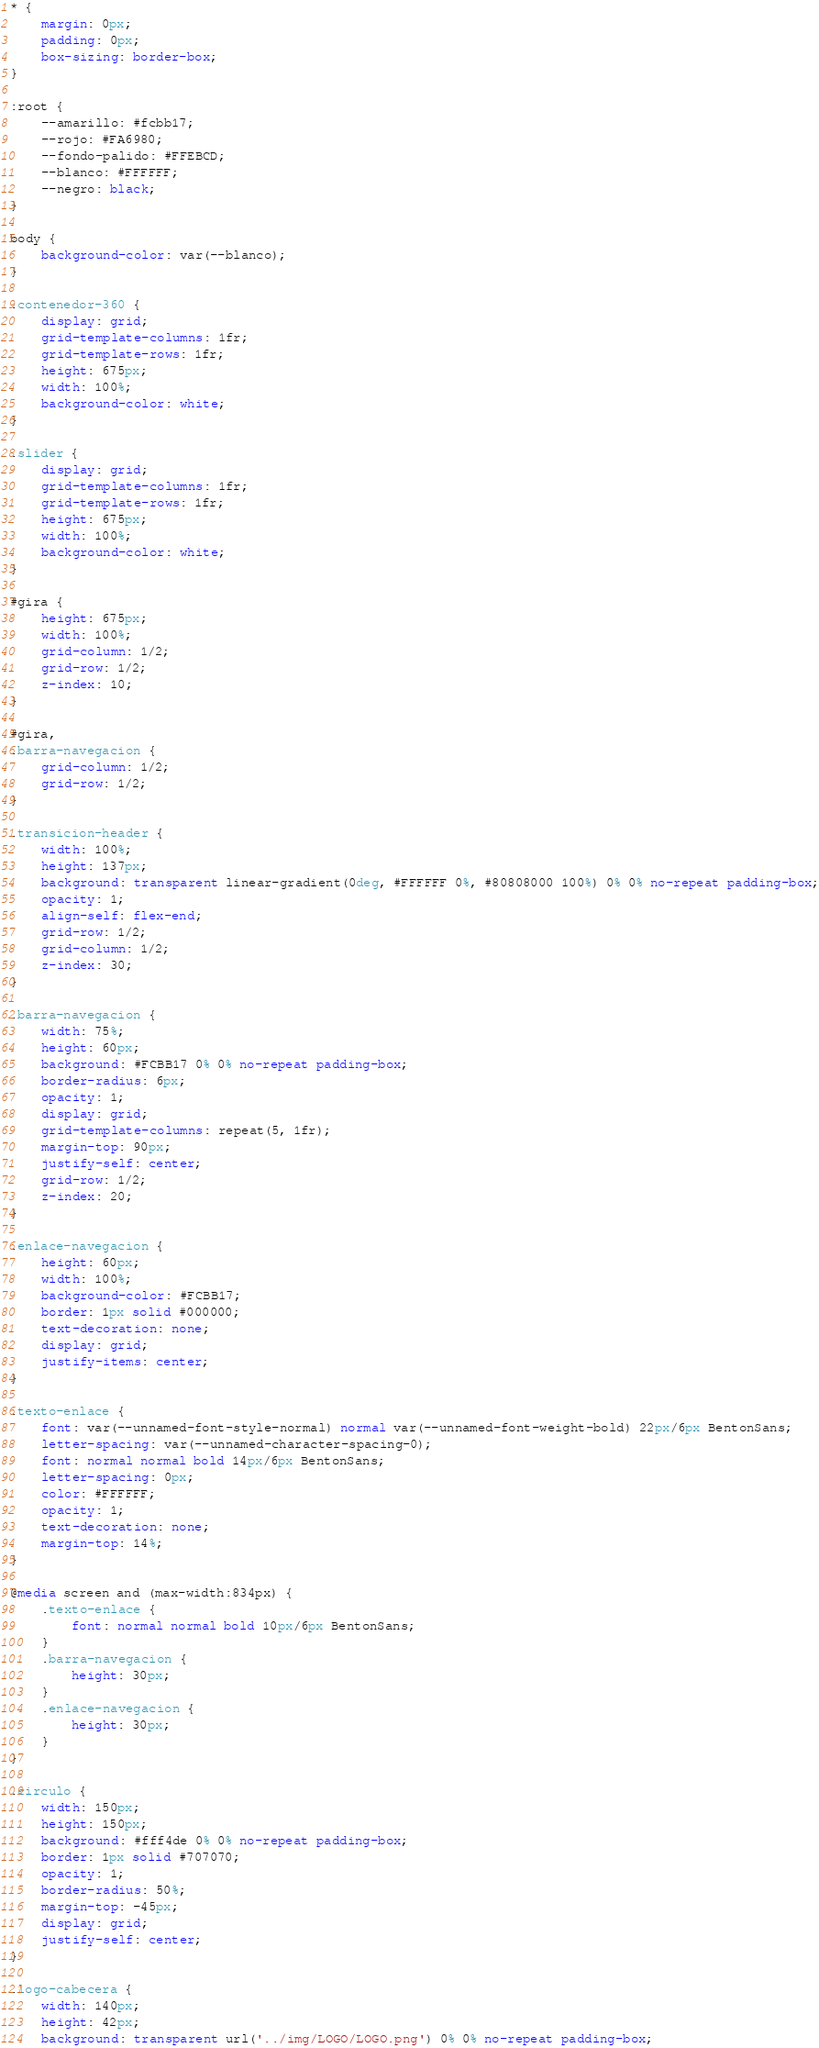<code> <loc_0><loc_0><loc_500><loc_500><_CSS_>* {
    margin: 0px;
    padding: 0px;
    box-sizing: border-box;
}

:root {
    --amarillo: #fcbb17;
    --rojo: #FA6980;
    --fondo-palido: #FFEBCD;
    --blanco: #FFFFFF;
    --negro: black;
}

body {
    background-color: var(--blanco);
}

.contenedor-360 {
    display: grid;
    grid-template-columns: 1fr;
    grid-template-rows: 1fr;
    height: 675px;
    width: 100%;
    background-color: white;
}

.slider {
    display: grid;
    grid-template-columns: 1fr;
    grid-template-rows: 1fr;
    height: 675px;
    width: 100%;
    background-color: white;
}

#gira {
    height: 675px;
    width: 100%;
    grid-column: 1/2;
    grid-row: 1/2;
    z-index: 10;
}

#gira,
.barra-navegacion {
    grid-column: 1/2;
    grid-row: 1/2;
}

.transicion-header {
    width: 100%;
    height: 137px;
    background: transparent linear-gradient(0deg, #FFFFFF 0%, #80808000 100%) 0% 0% no-repeat padding-box;
    opacity: 1;
    align-self: flex-end;
    grid-row: 1/2;
    grid-column: 1/2;
    z-index: 30;
}

.barra-navegacion {
    width: 75%;
    height: 60px;
    background: #FCBB17 0% 0% no-repeat padding-box;
    border-radius: 6px;
    opacity: 1;
    display: grid;
    grid-template-columns: repeat(5, 1fr);
    margin-top: 90px;
    justify-self: center;
    grid-row: 1/2;
    z-index: 20;
}

.enlace-navegacion {
    height: 60px;
    width: 100%;
    background-color: #FCBB17;
    border: 1px solid #000000;
    text-decoration: none;
    display: grid;
    justify-items: center;
}

.texto-enlace {
    font: var(--unnamed-font-style-normal) normal var(--unnamed-font-weight-bold) 22px/6px BentonSans;
    letter-spacing: var(--unnamed-character-spacing-0);
    font: normal normal bold 14px/6px BentonSans;
    letter-spacing: 0px;
    color: #FFFFFF;
    opacity: 1;
    text-decoration: none;
    margin-top: 14%;
}

@media screen and (max-width:834px) {
    .texto-enlace {
        font: normal normal bold 10px/6px BentonSans;
    }
    .barra-navegacion {
        height: 30px;
    }
    .enlace-navegacion {
        height: 30px;
    }
}

.circulo {
    width: 150px;
    height: 150px;
    background: #fff4de 0% 0% no-repeat padding-box;
    border: 1px solid #707070;
    opacity: 1;
    border-radius: 50%;
    margin-top: -45px;
    display: grid;
    justify-self: center;
}

.logo-cabecera {
    width: 140px;
    height: 42px;
    background: transparent url('../img/LOGO/LOGO.png') 0% 0% no-repeat padding-box;</code> 